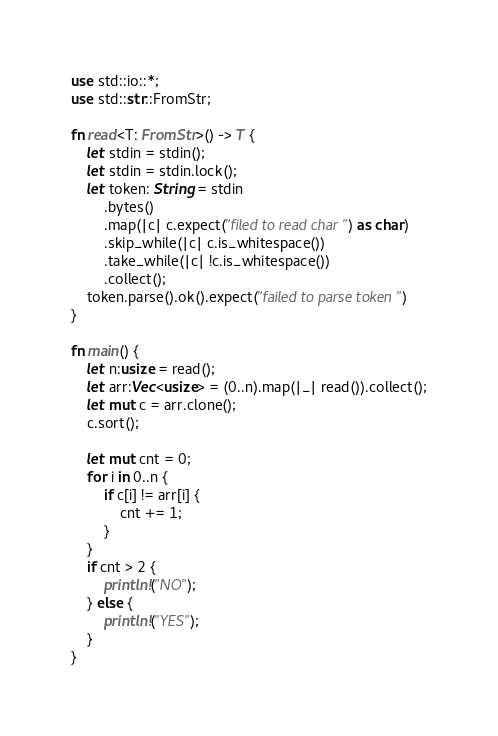<code> <loc_0><loc_0><loc_500><loc_500><_Rust_>use std::io::*;
use std::str::FromStr;

fn read<T: FromStr>() -> T {
    let stdin = stdin();
    let stdin = stdin.lock();
    let token: String = stdin
        .bytes()
        .map(|c| c.expect("filed to read char") as char)
        .skip_while(|c| c.is_whitespace())
        .take_while(|c| !c.is_whitespace())
        .collect();
    token.parse().ok().expect("failed to parse token")
}

fn main() {
    let n:usize = read();
    let arr:Vec<usize> = (0..n).map(|_| read()).collect();
    let mut c = arr.clone();
    c.sort();

    let mut cnt = 0;
    for i in 0..n {
        if c[i] != arr[i] {
            cnt += 1;
        }
    }
    if cnt > 2 {
        println!("NO");
    } else {
        println!("YES");
    }
}
</code> 